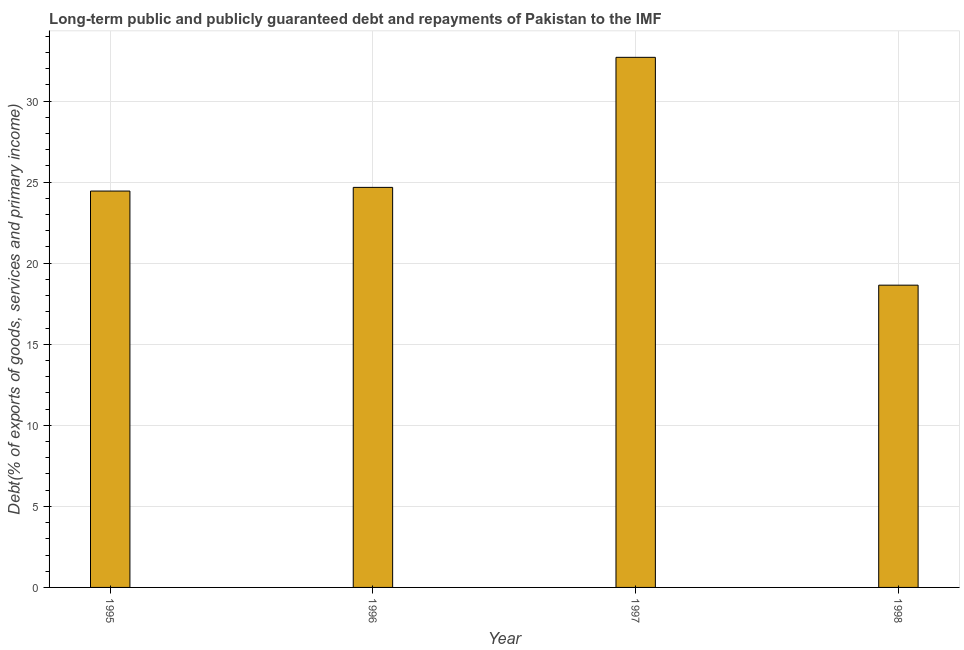What is the title of the graph?
Your response must be concise. Long-term public and publicly guaranteed debt and repayments of Pakistan to the IMF. What is the label or title of the X-axis?
Make the answer very short. Year. What is the label or title of the Y-axis?
Offer a very short reply. Debt(% of exports of goods, services and primary income). What is the debt service in 1997?
Make the answer very short. 32.7. Across all years, what is the maximum debt service?
Give a very brief answer. 32.7. Across all years, what is the minimum debt service?
Provide a short and direct response. 18.64. In which year was the debt service maximum?
Offer a terse response. 1997. In which year was the debt service minimum?
Ensure brevity in your answer.  1998. What is the sum of the debt service?
Your answer should be very brief. 100.47. What is the difference between the debt service in 1997 and 1998?
Provide a succinct answer. 14.05. What is the average debt service per year?
Your answer should be compact. 25.12. What is the median debt service?
Ensure brevity in your answer.  24.56. In how many years, is the debt service greater than 23 %?
Offer a terse response. 3. What is the ratio of the debt service in 1995 to that in 1996?
Offer a very short reply. 0.99. Is the difference between the debt service in 1995 and 1997 greater than the difference between any two years?
Your response must be concise. No. What is the difference between the highest and the second highest debt service?
Provide a succinct answer. 8.02. Is the sum of the debt service in 1995 and 1997 greater than the maximum debt service across all years?
Ensure brevity in your answer.  Yes. What is the difference between the highest and the lowest debt service?
Keep it short and to the point. 14.05. How many bars are there?
Give a very brief answer. 4. What is the difference between two consecutive major ticks on the Y-axis?
Keep it short and to the point. 5. Are the values on the major ticks of Y-axis written in scientific E-notation?
Your answer should be very brief. No. What is the Debt(% of exports of goods, services and primary income) of 1995?
Provide a short and direct response. 24.45. What is the Debt(% of exports of goods, services and primary income) in 1996?
Give a very brief answer. 24.68. What is the Debt(% of exports of goods, services and primary income) of 1997?
Provide a succinct answer. 32.7. What is the Debt(% of exports of goods, services and primary income) of 1998?
Your answer should be very brief. 18.64. What is the difference between the Debt(% of exports of goods, services and primary income) in 1995 and 1996?
Offer a very short reply. -0.23. What is the difference between the Debt(% of exports of goods, services and primary income) in 1995 and 1997?
Your answer should be compact. -8.25. What is the difference between the Debt(% of exports of goods, services and primary income) in 1995 and 1998?
Your answer should be compact. 5.81. What is the difference between the Debt(% of exports of goods, services and primary income) in 1996 and 1997?
Provide a succinct answer. -8.02. What is the difference between the Debt(% of exports of goods, services and primary income) in 1996 and 1998?
Offer a very short reply. 6.03. What is the difference between the Debt(% of exports of goods, services and primary income) in 1997 and 1998?
Provide a short and direct response. 14.05. What is the ratio of the Debt(% of exports of goods, services and primary income) in 1995 to that in 1996?
Offer a very short reply. 0.99. What is the ratio of the Debt(% of exports of goods, services and primary income) in 1995 to that in 1997?
Provide a succinct answer. 0.75. What is the ratio of the Debt(% of exports of goods, services and primary income) in 1995 to that in 1998?
Your response must be concise. 1.31. What is the ratio of the Debt(% of exports of goods, services and primary income) in 1996 to that in 1997?
Provide a short and direct response. 0.76. What is the ratio of the Debt(% of exports of goods, services and primary income) in 1996 to that in 1998?
Your response must be concise. 1.32. What is the ratio of the Debt(% of exports of goods, services and primary income) in 1997 to that in 1998?
Your answer should be compact. 1.75. 